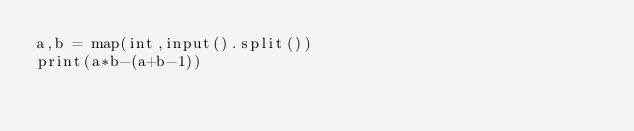Convert code to text. <code><loc_0><loc_0><loc_500><loc_500><_Python_>a,b = map(int,input().split())
print(a*b-(a+b-1))
</code> 